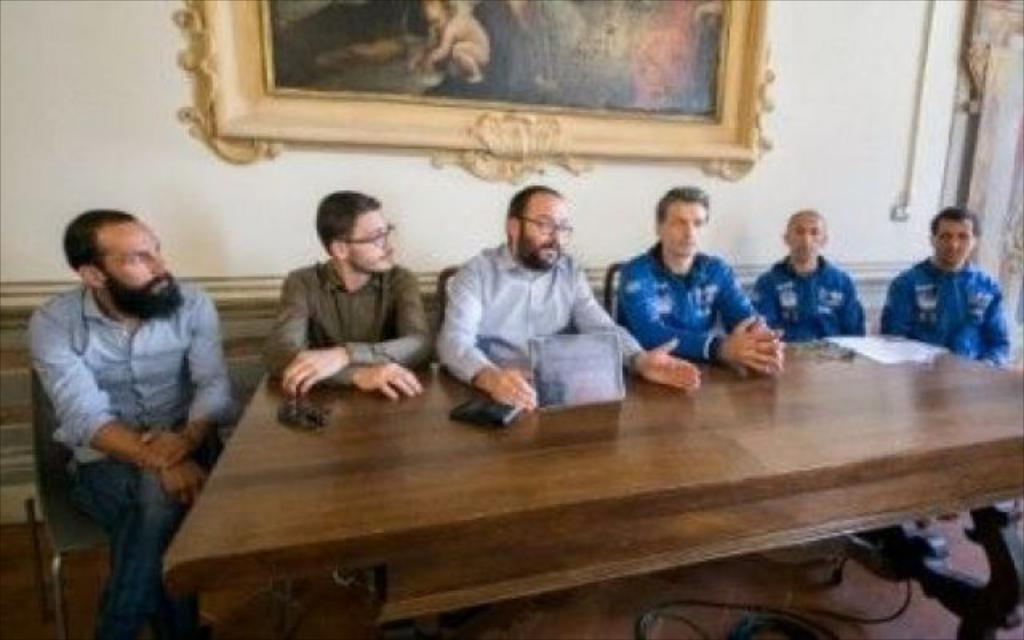What are the people in the image doing? The people in the image are sitting in front of a table. Can you describe anything on the wall in the background? There is a photo frame on the wall in the background. What type of string is being used to turn the page in the image? There is no string or page present in the image; it only shows people sitting in front of a table and a photo frame on the wall in the background. 